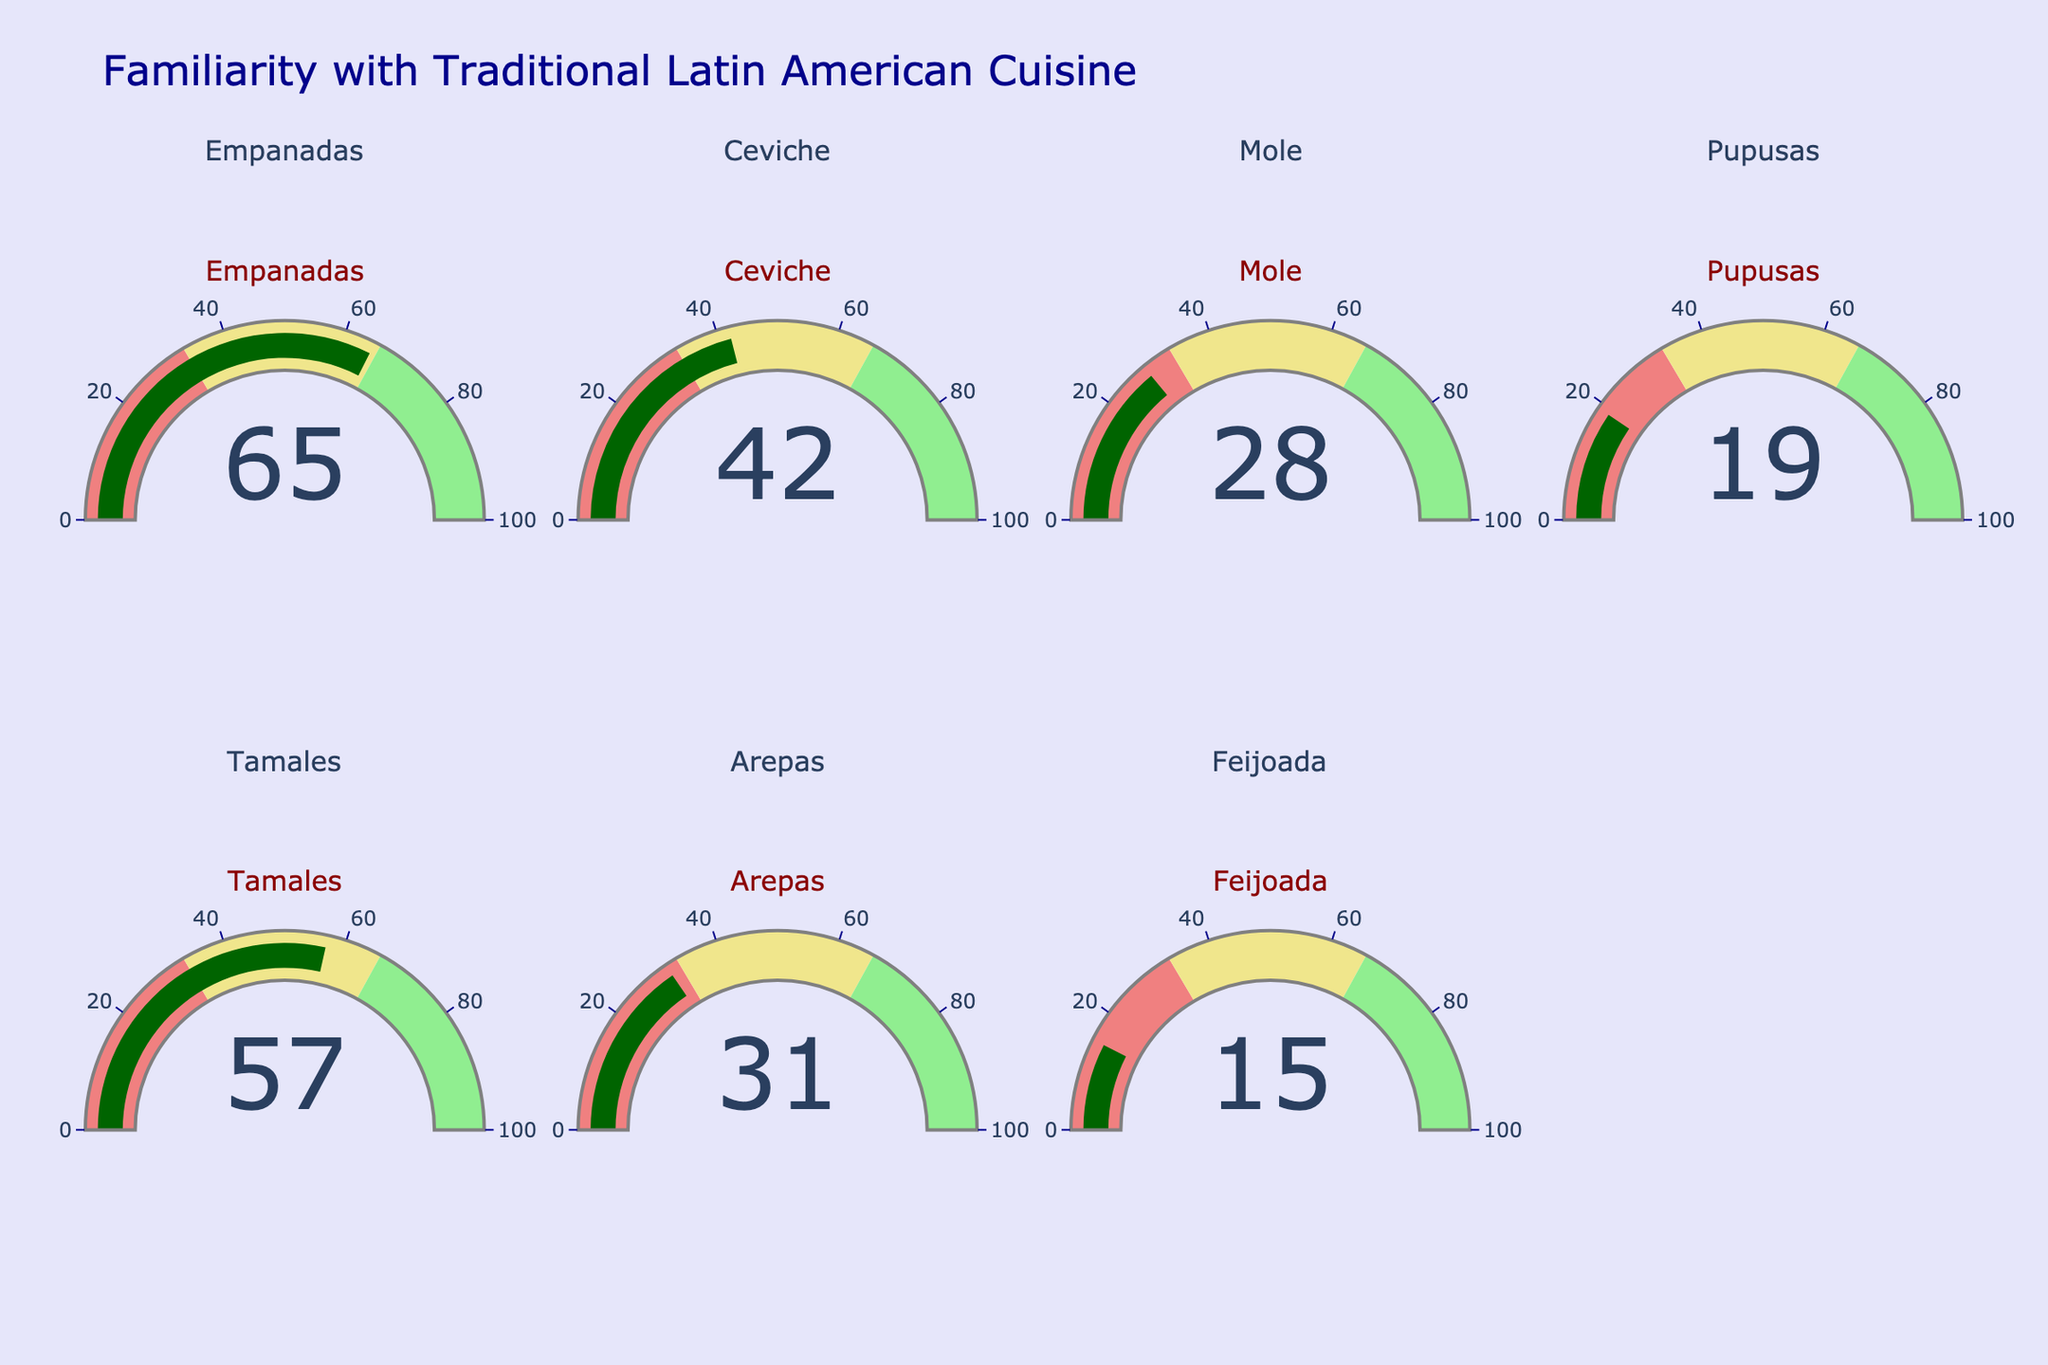What's the highest familiarity score displayed in the figure? Look at each gauge chart and identify the one with the highest value. The highest value among Empanadas (65), Ceviche (42), Mole (28), Pupusas (19), Tamales (57), Arepas (31), Feijoada (15) is 65.
Answer: 65 What's the title of the figure? The title is usually positioned at the top of the figure. It reads "Familiarity with Traditional Latin American Cuisine".
Answer: Familiarity with Traditional Latin American Cuisine How many dishes have a familiarity score less than 30? Count the gauges with values less than 30. Mole (28), Pupusas (19), and Feijoada (15) are the ones with values less than 30.
Answer: 3 What's the familiarity score for Tamales? Locate the gauge labeled "Tamales" and observe the value shown on it.
Answer: 57 Which dish has the lowest familiarity score? Compare all the values on the gauges and find the lowest one. Feijoada has the lowest score with 15.
Answer: Feijoada How many gauges are in the figure? Count all the gauge charts displayed in the figure. There are 7 gauges corresponding to the dishes.
Answer: 7 What is the range of values marked on each gauge? Each gauge has an axis with a range marked from 0 to 100.
Answer: 0 to 100 What is the average familiarity score for all displayed dishes? Sum up all the scores and divide by the number of dishes: (65 + 42 + 28 + 19 + 57 + 31 + 15) / 7 = 257 / 7 = 36.71
Answer: 36.71 Which dish has a familiarity score closest to 50? Compare the displayed values to 50 and find the closest one. Tamales with 57 is the closest to 50.
Answer: Tamales How much higher is the score of Empanadas compared to Pupusas? Subtract the score of Pupusas from Empanadas: 65 - 19 = 46
Answer: 46 